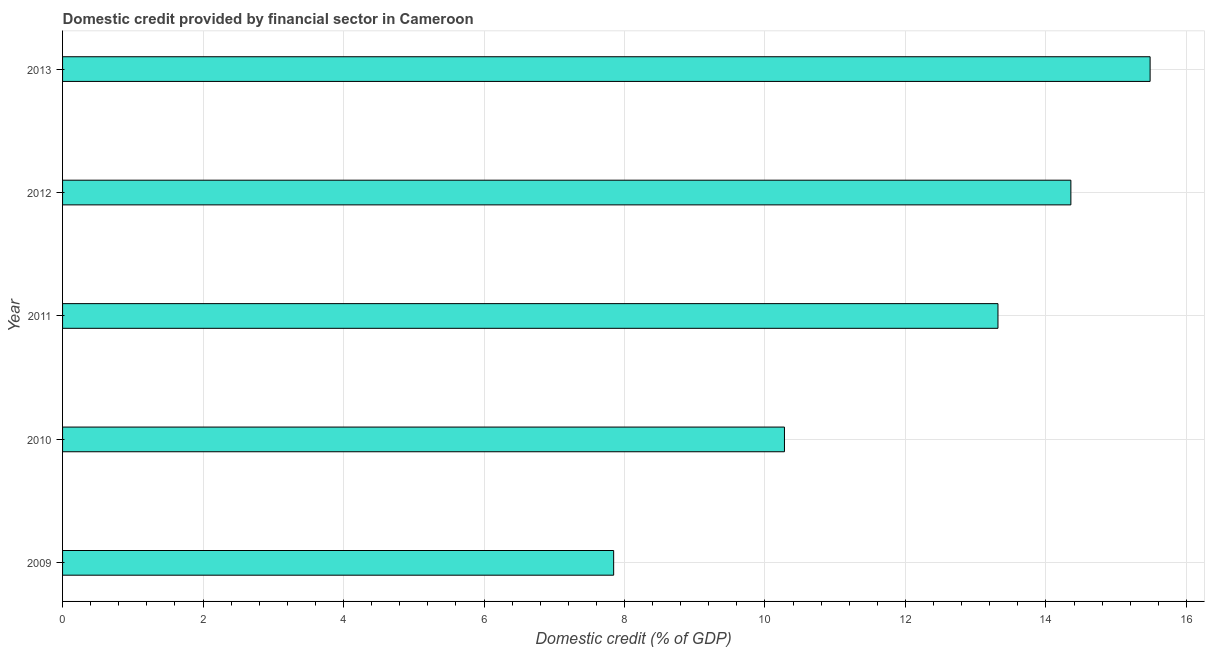Does the graph contain grids?
Ensure brevity in your answer.  Yes. What is the title of the graph?
Offer a terse response. Domestic credit provided by financial sector in Cameroon. What is the label or title of the X-axis?
Provide a succinct answer. Domestic credit (% of GDP). What is the label or title of the Y-axis?
Provide a short and direct response. Year. What is the domestic credit provided by financial sector in 2011?
Keep it short and to the point. 13.32. Across all years, what is the maximum domestic credit provided by financial sector?
Your answer should be very brief. 15.48. Across all years, what is the minimum domestic credit provided by financial sector?
Offer a very short reply. 7.85. In which year was the domestic credit provided by financial sector maximum?
Offer a terse response. 2013. In which year was the domestic credit provided by financial sector minimum?
Provide a succinct answer. 2009. What is the sum of the domestic credit provided by financial sector?
Keep it short and to the point. 61.28. What is the difference between the domestic credit provided by financial sector in 2009 and 2010?
Offer a very short reply. -2.43. What is the average domestic credit provided by financial sector per year?
Provide a short and direct response. 12.26. What is the median domestic credit provided by financial sector?
Provide a short and direct response. 13.32. Do a majority of the years between 2013 and 2012 (inclusive) have domestic credit provided by financial sector greater than 10 %?
Your answer should be compact. No. What is the ratio of the domestic credit provided by financial sector in 2009 to that in 2010?
Your answer should be compact. 0.76. Is the domestic credit provided by financial sector in 2009 less than that in 2011?
Offer a terse response. Yes. What is the difference between the highest and the second highest domestic credit provided by financial sector?
Give a very brief answer. 1.13. Is the sum of the domestic credit provided by financial sector in 2009 and 2010 greater than the maximum domestic credit provided by financial sector across all years?
Your answer should be very brief. Yes. What is the difference between the highest and the lowest domestic credit provided by financial sector?
Your answer should be compact. 7.64. How many bars are there?
Give a very brief answer. 5. What is the difference between two consecutive major ticks on the X-axis?
Your answer should be very brief. 2. What is the Domestic credit (% of GDP) in 2009?
Offer a very short reply. 7.85. What is the Domestic credit (% of GDP) in 2010?
Provide a succinct answer. 10.28. What is the Domestic credit (% of GDP) of 2011?
Offer a terse response. 13.32. What is the Domestic credit (% of GDP) in 2012?
Provide a succinct answer. 14.35. What is the Domestic credit (% of GDP) of 2013?
Your answer should be compact. 15.48. What is the difference between the Domestic credit (% of GDP) in 2009 and 2010?
Ensure brevity in your answer.  -2.43. What is the difference between the Domestic credit (% of GDP) in 2009 and 2011?
Your answer should be very brief. -5.47. What is the difference between the Domestic credit (% of GDP) in 2009 and 2012?
Give a very brief answer. -6.51. What is the difference between the Domestic credit (% of GDP) in 2009 and 2013?
Offer a terse response. -7.64. What is the difference between the Domestic credit (% of GDP) in 2010 and 2011?
Give a very brief answer. -3.04. What is the difference between the Domestic credit (% of GDP) in 2010 and 2012?
Your answer should be very brief. -4.08. What is the difference between the Domestic credit (% of GDP) in 2010 and 2013?
Make the answer very short. -5.21. What is the difference between the Domestic credit (% of GDP) in 2011 and 2012?
Give a very brief answer. -1.04. What is the difference between the Domestic credit (% of GDP) in 2011 and 2013?
Your answer should be compact. -2.17. What is the difference between the Domestic credit (% of GDP) in 2012 and 2013?
Provide a short and direct response. -1.13. What is the ratio of the Domestic credit (% of GDP) in 2009 to that in 2010?
Your answer should be compact. 0.76. What is the ratio of the Domestic credit (% of GDP) in 2009 to that in 2011?
Ensure brevity in your answer.  0.59. What is the ratio of the Domestic credit (% of GDP) in 2009 to that in 2012?
Give a very brief answer. 0.55. What is the ratio of the Domestic credit (% of GDP) in 2009 to that in 2013?
Keep it short and to the point. 0.51. What is the ratio of the Domestic credit (% of GDP) in 2010 to that in 2011?
Provide a succinct answer. 0.77. What is the ratio of the Domestic credit (% of GDP) in 2010 to that in 2012?
Keep it short and to the point. 0.72. What is the ratio of the Domestic credit (% of GDP) in 2010 to that in 2013?
Keep it short and to the point. 0.66. What is the ratio of the Domestic credit (% of GDP) in 2011 to that in 2012?
Keep it short and to the point. 0.93. What is the ratio of the Domestic credit (% of GDP) in 2011 to that in 2013?
Provide a short and direct response. 0.86. What is the ratio of the Domestic credit (% of GDP) in 2012 to that in 2013?
Keep it short and to the point. 0.93. 